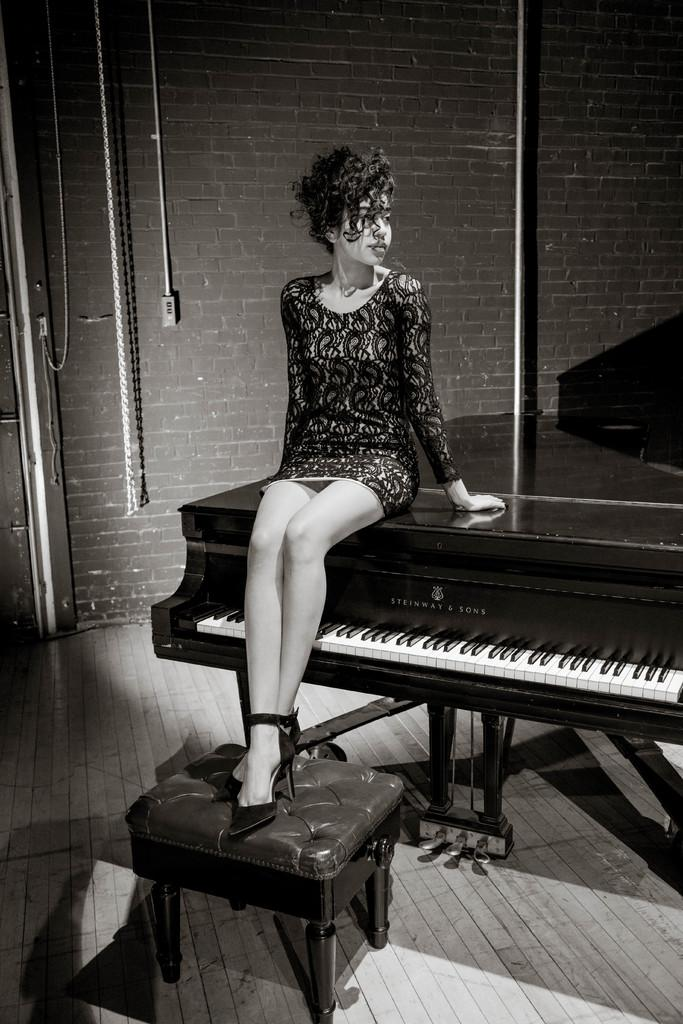Who is the main subject in the image? There is a girl in the image. What is the girl sitting on? The girl is sitting on a piano. What is the girl doing with her legs? The girl is resting her legs on a table. What year is the girl playing the spade in the image? There is no spade or reference to a specific year in the image. 